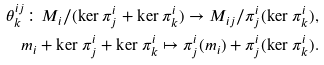<formula> <loc_0><loc_0><loc_500><loc_500>\theta ^ { i j } _ { k } \colon M _ { i } / ( \ker \pi ^ { i } _ { j } + \ker \pi ^ { i } _ { k } ) \rightarrow M _ { i j } / \pi ^ { i } _ { j } ( \ker \pi ^ { i } _ { k } ) , \\ m _ { i } + \ker \pi ^ { i } _ { j } + \ker \pi ^ { i } _ { k } \mapsto \pi ^ { i } _ { j } ( m _ { i } ) + \pi ^ { i } _ { j } ( \ker \pi ^ { i } _ { k } ) .</formula> 